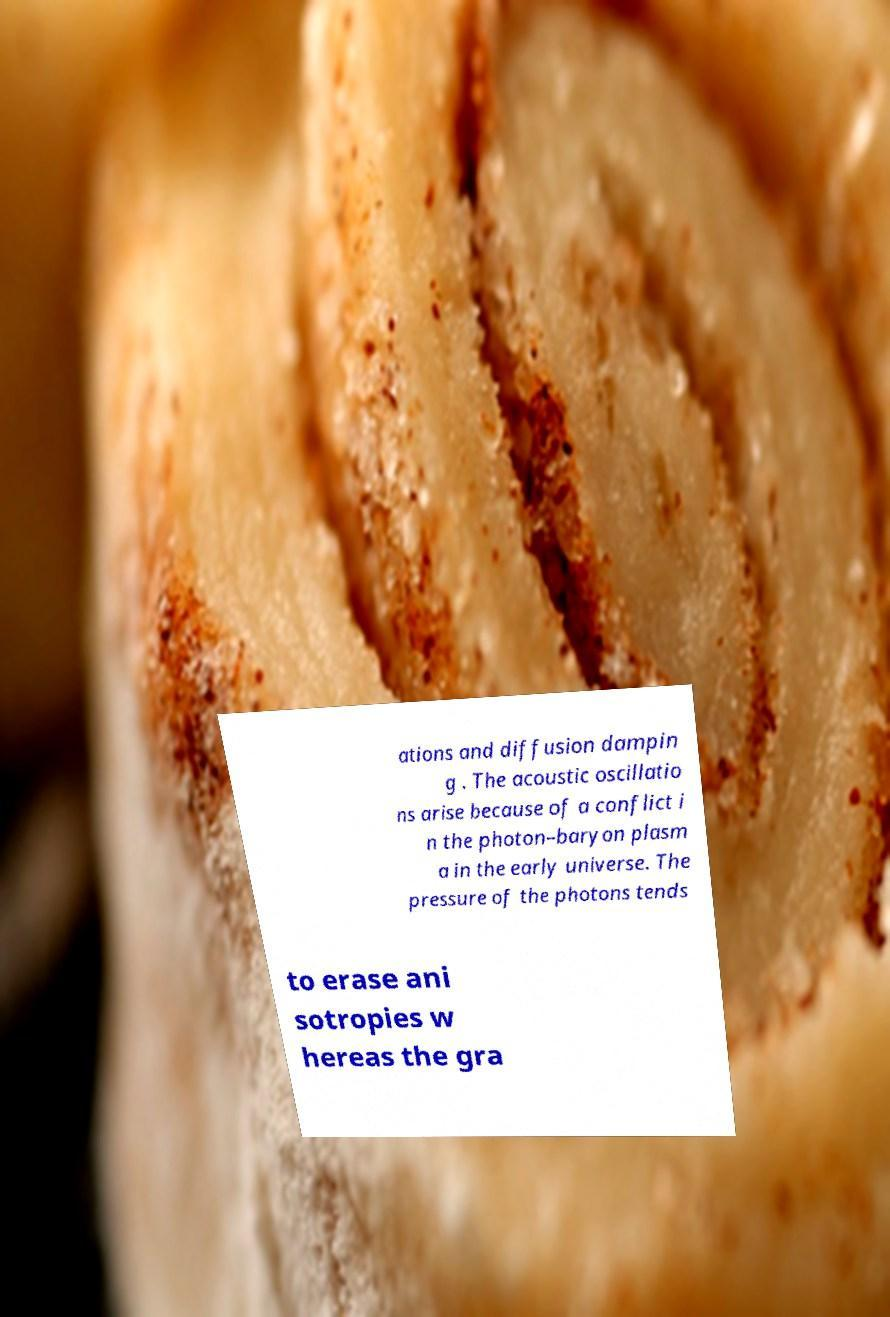Could you extract and type out the text from this image? ations and diffusion dampin g . The acoustic oscillatio ns arise because of a conflict i n the photon–baryon plasm a in the early universe. The pressure of the photons tends to erase ani sotropies w hereas the gra 